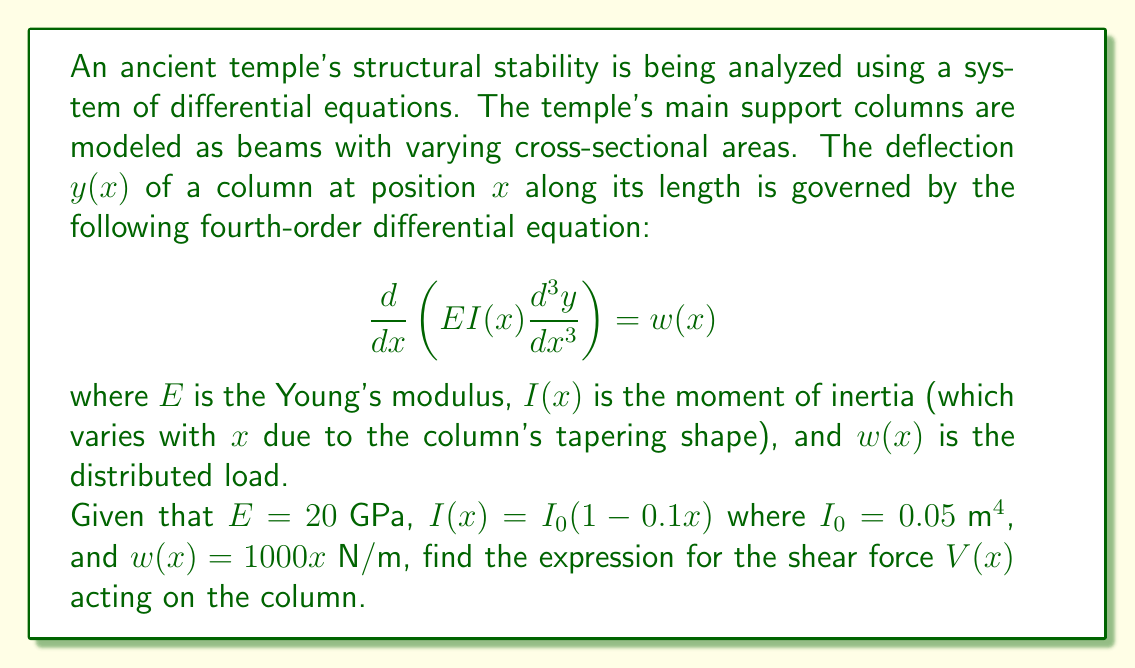What is the answer to this math problem? To solve this problem, we need to follow these steps:

1) First, let's expand the left side of the given equation:

   $$\frac{d}{dx}\left(EI(x)\frac{d^3y}{dx^3}\right) = E\frac{d}{dx}\left(I(x)\frac{d^3y}{dx^3}\right) = E\left(I'(x)\frac{d^3y}{dx^3} + I(x)\frac{d^4y}{dx^4}\right)$$

2) Now, we can equate this to $w(x)$:

   $$E\left(I'(x)\frac{d^3y}{dx^3} + I(x)\frac{d^4y}{dx^4}\right) = w(x)$$

3) In structural mechanics, the shear force $V(x)$ is related to the third derivative of deflection:

   $$V(x) = EI(x)\frac{d^3y}{dx^3}$$

4) We need to find an expression for $\frac{d^3y}{dx^3}$. Let's rearrange our equation:

   $$I(x)\frac{d^4y}{dx^4} + I'(x)\frac{d^3y}{dx^3} = \frac{w(x)}{E}$$

5) Substitute the given values:
   
   $I(x) = I_0(1-0.1x) = 0.05(1-0.1x)$
   $I'(x) = -0.005$
   $w(x) = 1000x$
   $E = 20 \times 10^9$

   $$(0.05-0.005x)\frac{d^4y}{dx^4} - 0.005\frac{d^3y}{dx^3} = \frac{1000x}{20 \times 10^9}$$

6) Simplify:

   $$(0.05-0.005x)\frac{d^4y}{dx^4} - 0.005\frac{d^3y}{dx^3} = 5 \times 10^{-8}x$$

7) Now, we can express $\frac{d^3y}{dx^3}$ in terms of $x$ and $\frac{d^4y}{dx^4}$:

   $$\frac{d^3y}{dx^3} = \frac{(0.05-0.005x)\frac{d^4y}{dx^4} - 5 \times 10^{-8}x}{0.005}$$

8) Substitute this into the expression for shear force:

   $$V(x) = EI(x)\frac{d^3y}{dx^3} = 20 \times 10^9 \times 0.05(1-0.1x) \times \frac{(0.05-0.005x)\frac{d^4y}{dx^4} - 5 \times 10^{-8}x}{0.005}$$

9) Simplify:

   $$V(x) = 2 \times 10^8(1-0.1x)((10-x)\frac{d^4y}{dx^4} - 10^{-8}x)$$

This is our final expression for the shear force $V(x)$.
Answer: $$V(x) = 2 \times 10^8(1-0.1x)((10-x)\frac{d^4y}{dx^4} - 10^{-8}x)$$ 